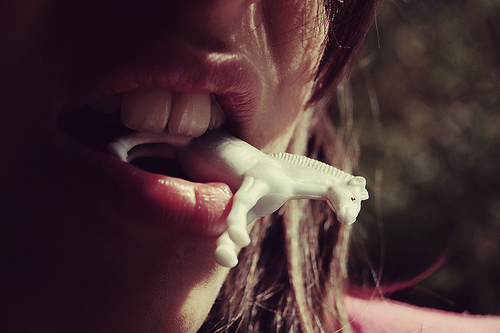<image>
Is there a toy under the tooth? Yes. The toy is positioned underneath the tooth, with the tooth above it in the vertical space. 